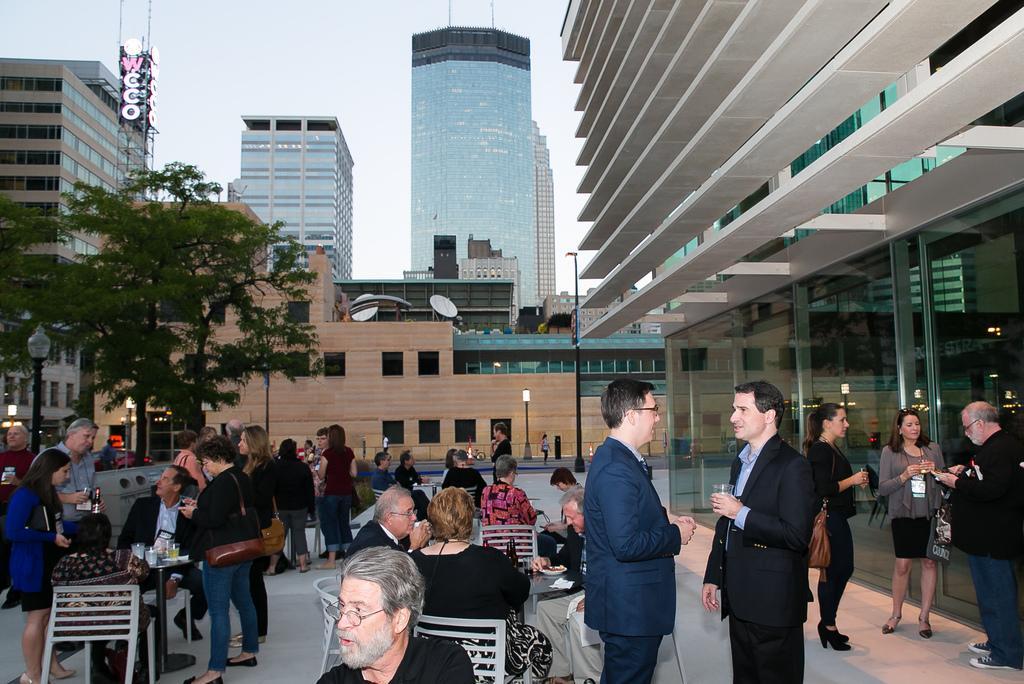In one or two sentences, can you explain what this image depicts? In the center of the image we can see a few people are sitting on the chairs. And we can see a few people are standing and few people are holding some objects. And we can see chairs, tables, one machine and a few other objects. On the table we can see glasses and a few other objects. In the background we can see the sky, clouds, buildings, towers, poles, trees, sign boards, banners, few people are standing and a few other objects. 